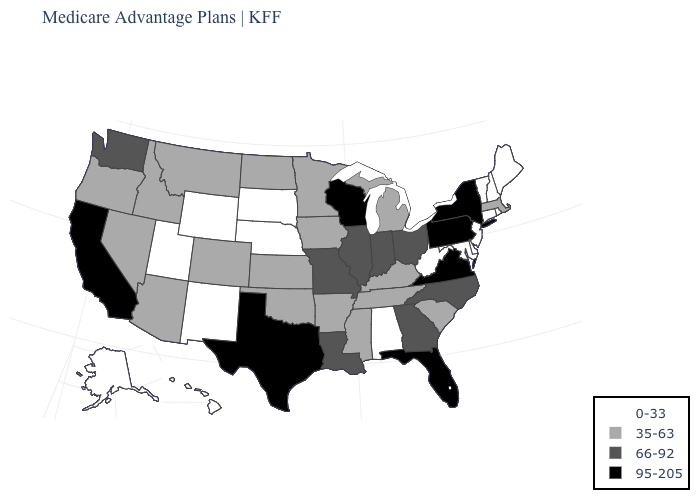Name the states that have a value in the range 0-33?
Concise answer only. Alaska, Alabama, Connecticut, Delaware, Hawaii, Maryland, Maine, Nebraska, New Hampshire, New Jersey, New Mexico, Rhode Island, South Dakota, Utah, Vermont, West Virginia, Wyoming. Name the states that have a value in the range 35-63?
Answer briefly. Arkansas, Arizona, Colorado, Iowa, Idaho, Kansas, Kentucky, Massachusetts, Michigan, Minnesota, Mississippi, Montana, North Dakota, Nevada, Oklahoma, Oregon, South Carolina, Tennessee. Which states have the lowest value in the USA?
Be succinct. Alaska, Alabama, Connecticut, Delaware, Hawaii, Maryland, Maine, Nebraska, New Hampshire, New Jersey, New Mexico, Rhode Island, South Dakota, Utah, Vermont, West Virginia, Wyoming. Name the states that have a value in the range 95-205?
Short answer required. California, Florida, New York, Pennsylvania, Texas, Virginia, Wisconsin. Does Florida have the highest value in the USA?
Answer briefly. Yes. Name the states that have a value in the range 0-33?
Answer briefly. Alaska, Alabama, Connecticut, Delaware, Hawaii, Maryland, Maine, Nebraska, New Hampshire, New Jersey, New Mexico, Rhode Island, South Dakota, Utah, Vermont, West Virginia, Wyoming. What is the lowest value in the West?
Be succinct. 0-33. Among the states that border Nebraska , does Missouri have the highest value?
Write a very short answer. Yes. Which states have the lowest value in the South?
Give a very brief answer. Alabama, Delaware, Maryland, West Virginia. Does South Dakota have the same value as Maine?
Concise answer only. Yes. Does Delaware have the highest value in the USA?
Answer briefly. No. Among the states that border Oklahoma , does Texas have the highest value?
Short answer required. Yes. Name the states that have a value in the range 0-33?
Concise answer only. Alaska, Alabama, Connecticut, Delaware, Hawaii, Maryland, Maine, Nebraska, New Hampshire, New Jersey, New Mexico, Rhode Island, South Dakota, Utah, Vermont, West Virginia, Wyoming. How many symbols are there in the legend?
Concise answer only. 4. Among the states that border Pennsylvania , which have the lowest value?
Concise answer only. Delaware, Maryland, New Jersey, West Virginia. 